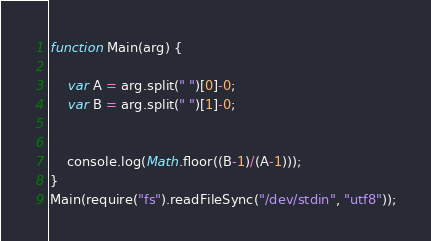Convert code to text. <code><loc_0><loc_0><loc_500><loc_500><_JavaScript_>function Main(arg) {
 
    var A = arg.split(" ")[0]-0;
    var B = arg.split(" ")[1]-0;


    console.log(Math.floor((B-1)/(A-1)));
}
Main(require("fs").readFileSync("/dev/stdin", "utf8"));
</code> 